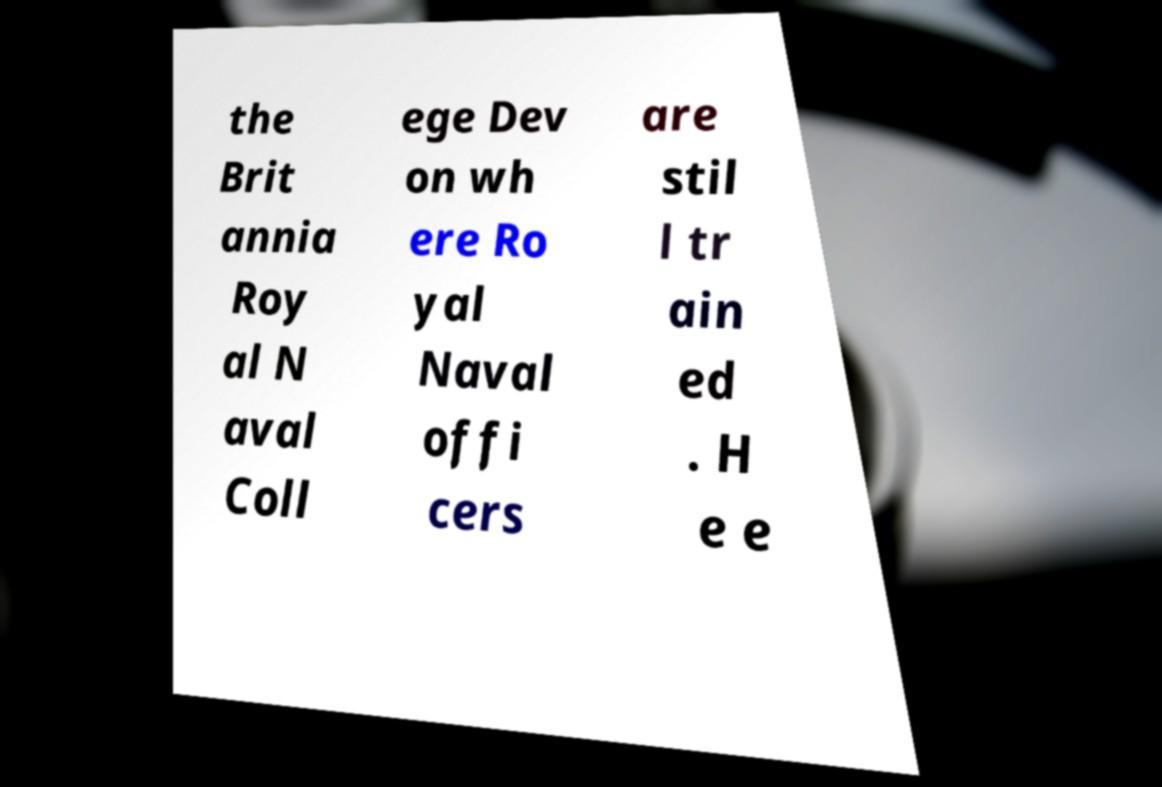Can you accurately transcribe the text from the provided image for me? the Brit annia Roy al N aval Coll ege Dev on wh ere Ro yal Naval offi cers are stil l tr ain ed . H e e 